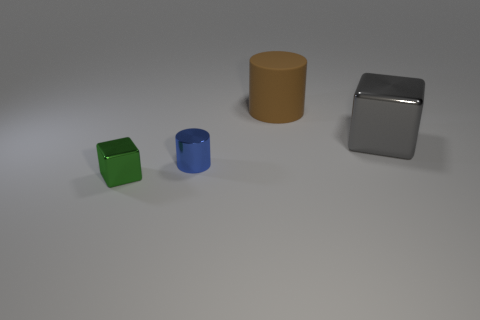What material is the thing that is both in front of the large brown object and right of the blue cylinder?
Give a very brief answer. Metal. Is the number of cylinders behind the gray metallic cube less than the number of blue metallic cylinders in front of the small blue cylinder?
Ensure brevity in your answer.  No. There is a gray object that is the same material as the tiny green cube; what size is it?
Give a very brief answer. Large. Is the blue thing made of the same material as the cylinder that is behind the shiny cylinder?
Provide a succinct answer. No. What material is the large thing that is the same shape as the tiny green object?
Ensure brevity in your answer.  Metal. Is there any other thing that is made of the same material as the brown thing?
Provide a short and direct response. No. Is the block that is to the right of the green metal block made of the same material as the cube that is in front of the large gray object?
Make the answer very short. Yes. There is a large object that is on the left side of the metallic cube that is behind the cylinder that is on the left side of the big rubber object; what is its color?
Your answer should be very brief. Brown. How many things are matte cylinders or small shiny things on the right side of the small green block?
Offer a very short reply. 2. Are there any objects of the same size as the gray cube?
Offer a terse response. Yes. 